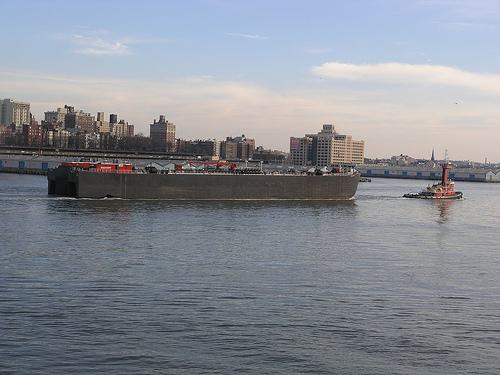Is there a boat in the image? Yes, there is a large boat in the foreground of the image, which appears to be a barge being tugged by a smaller tugboat. The scene likely indicates an active waterway being used for transportation. 